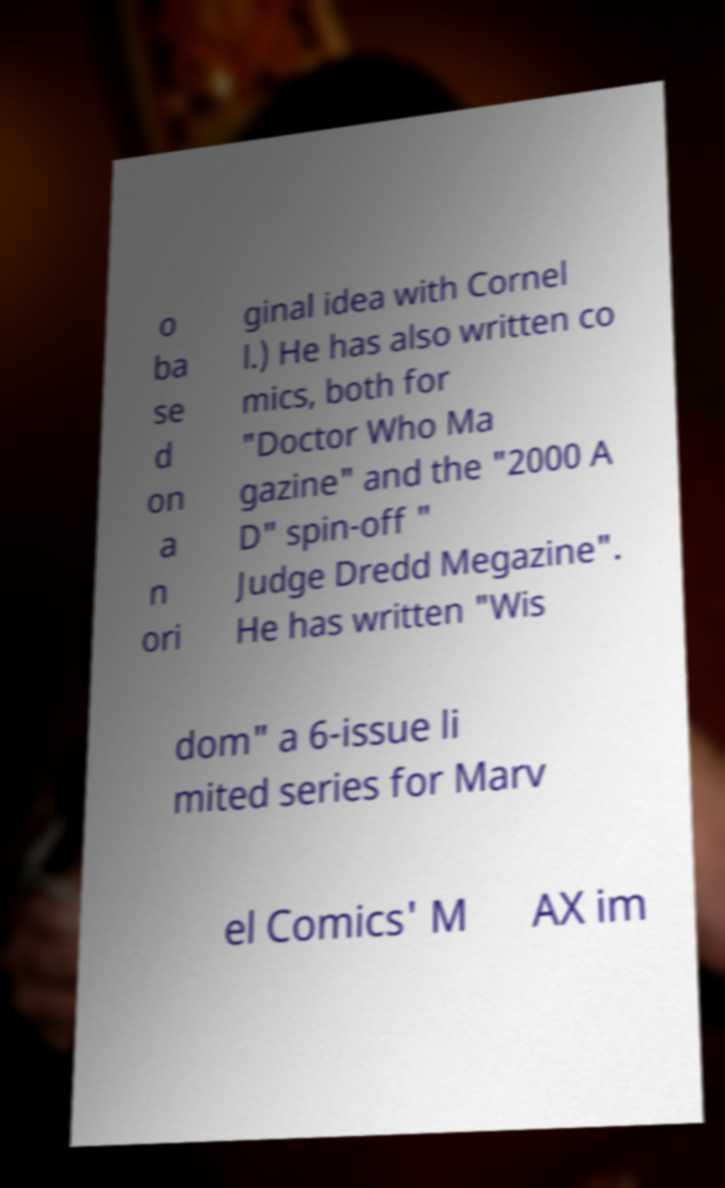Could you extract and type out the text from this image? o ba se d on a n ori ginal idea with Cornel l.) He has also written co mics, both for "Doctor Who Ma gazine" and the "2000 A D" spin-off " Judge Dredd Megazine". He has written "Wis dom" a 6-issue li mited series for Marv el Comics' M AX im 